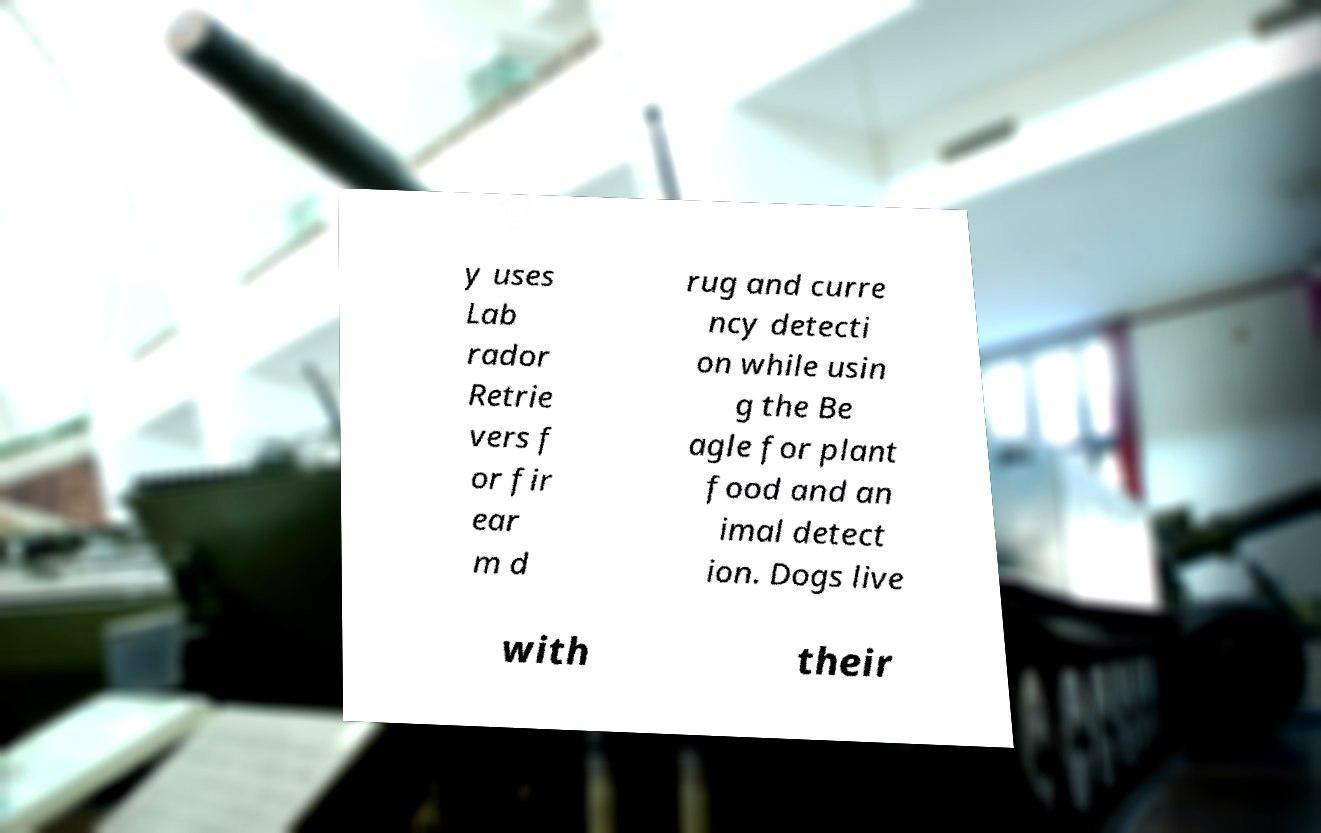Please identify and transcribe the text found in this image. y uses Lab rador Retrie vers f or fir ear m d rug and curre ncy detecti on while usin g the Be agle for plant food and an imal detect ion. Dogs live with their 